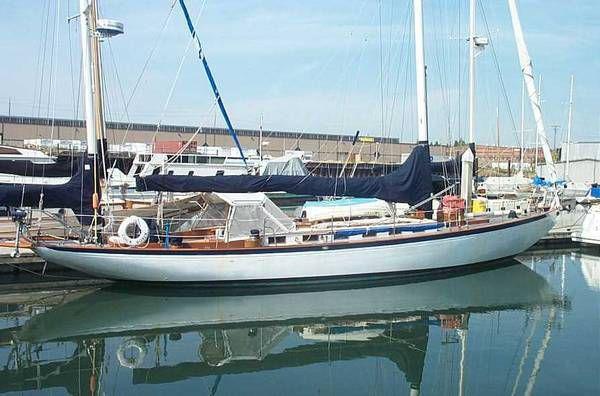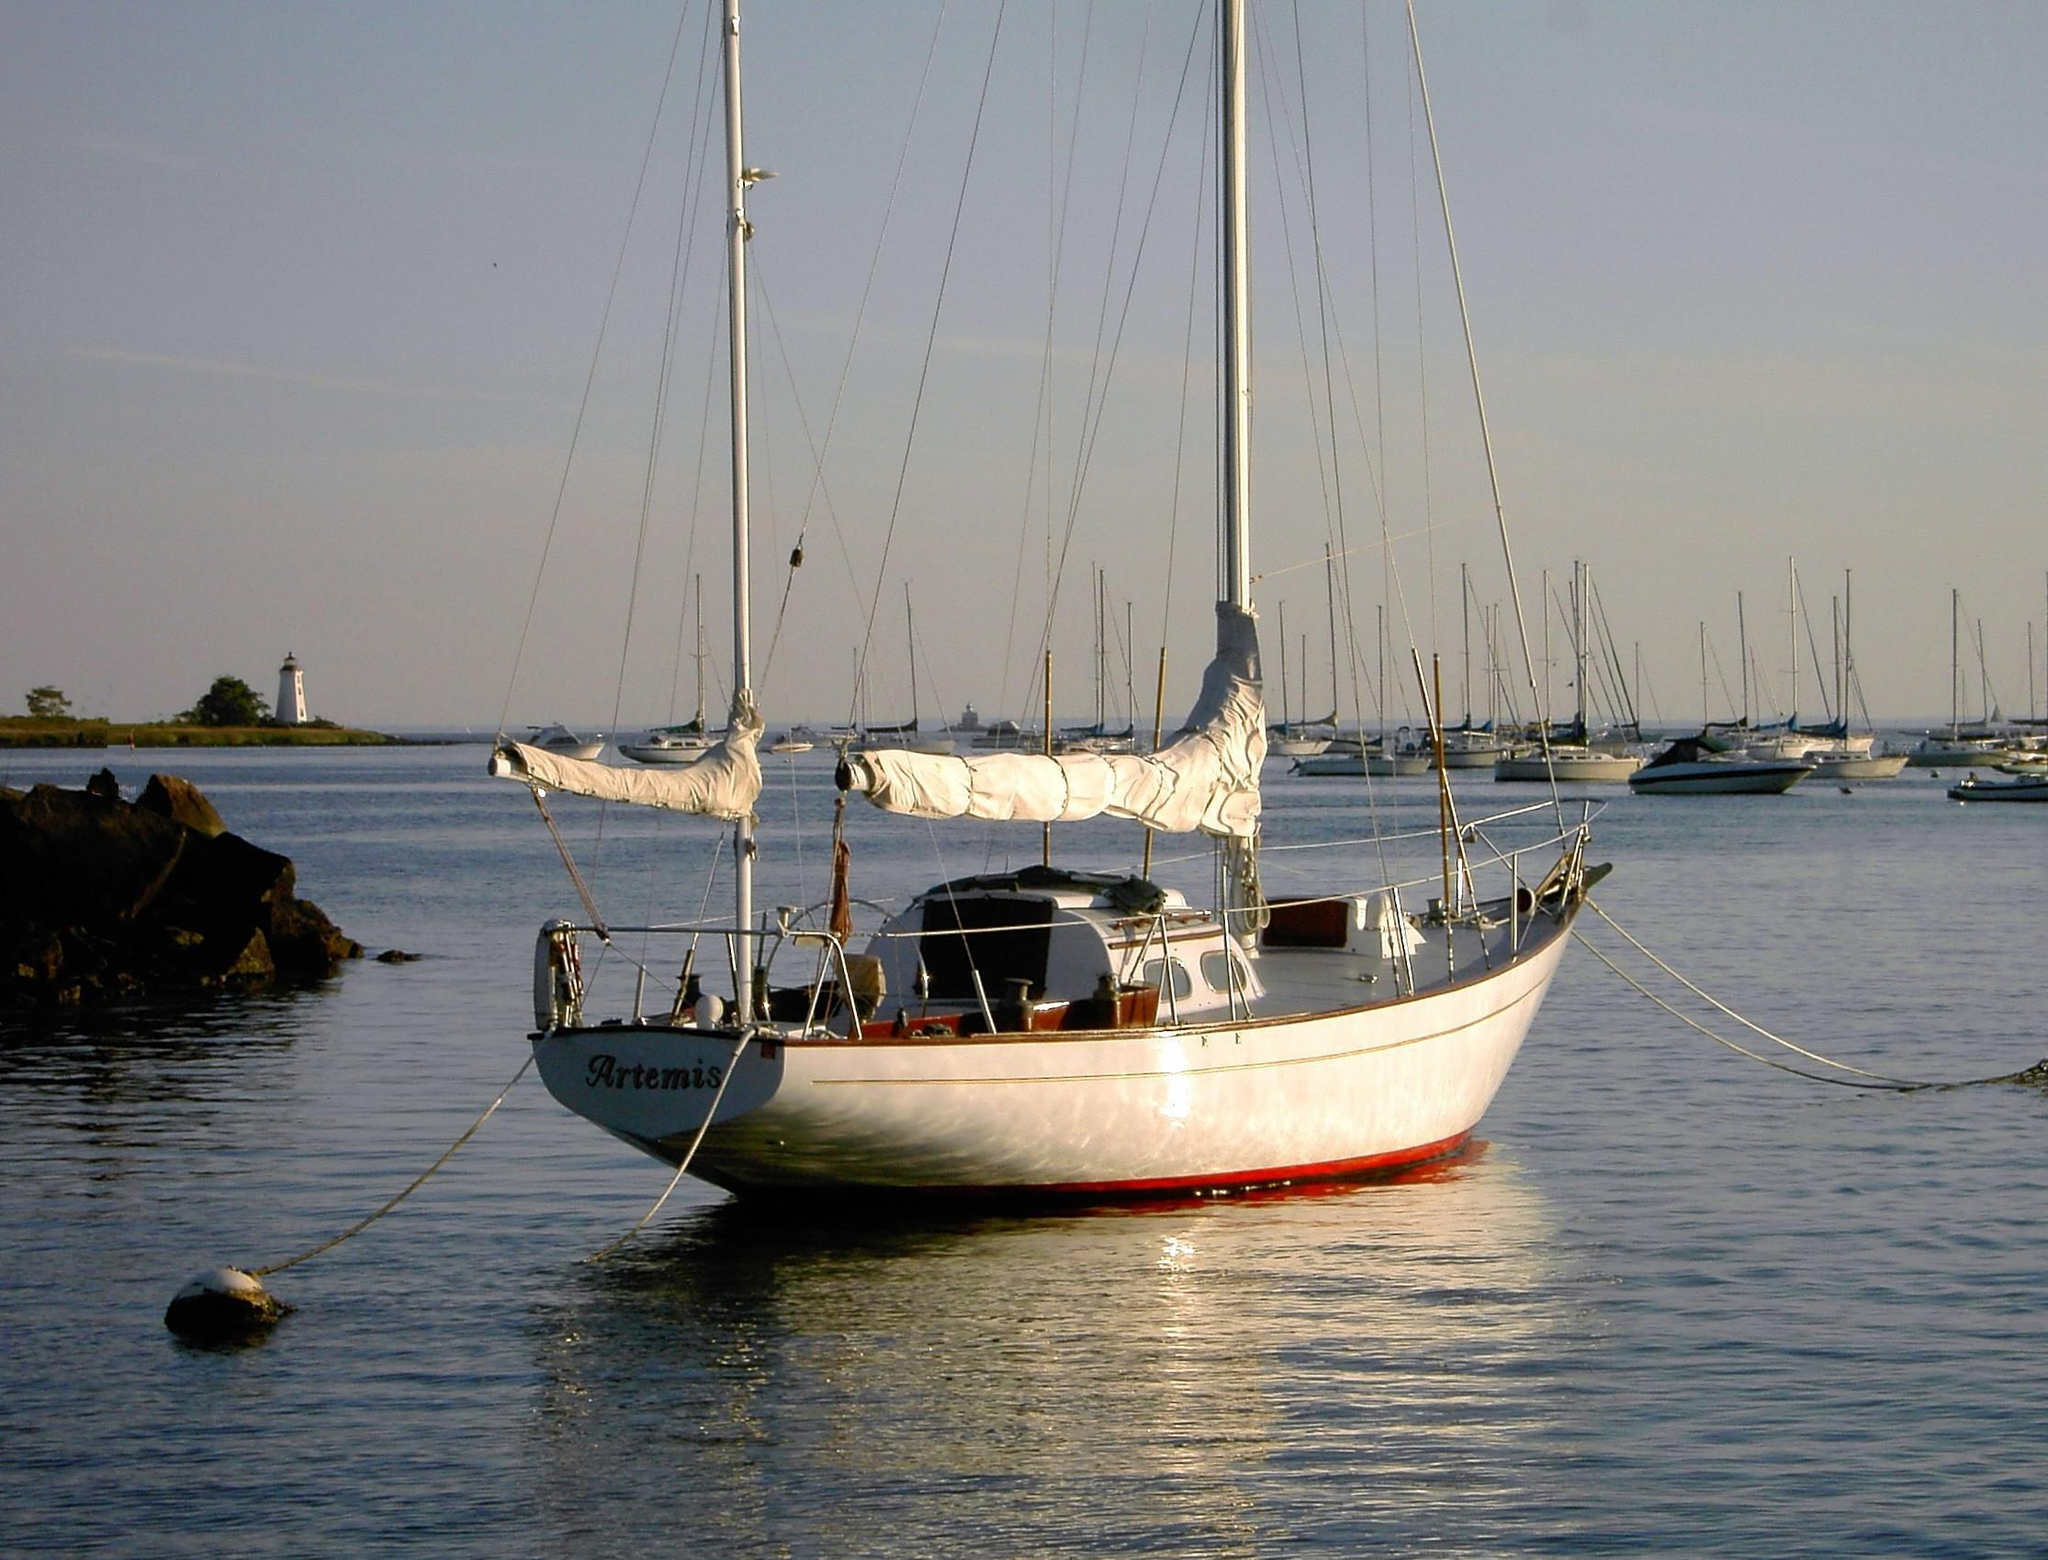The first image is the image on the left, the second image is the image on the right. Evaluate the accuracy of this statement regarding the images: "There are three white sails in the image on the left.". Is it true? Answer yes or no. No. 